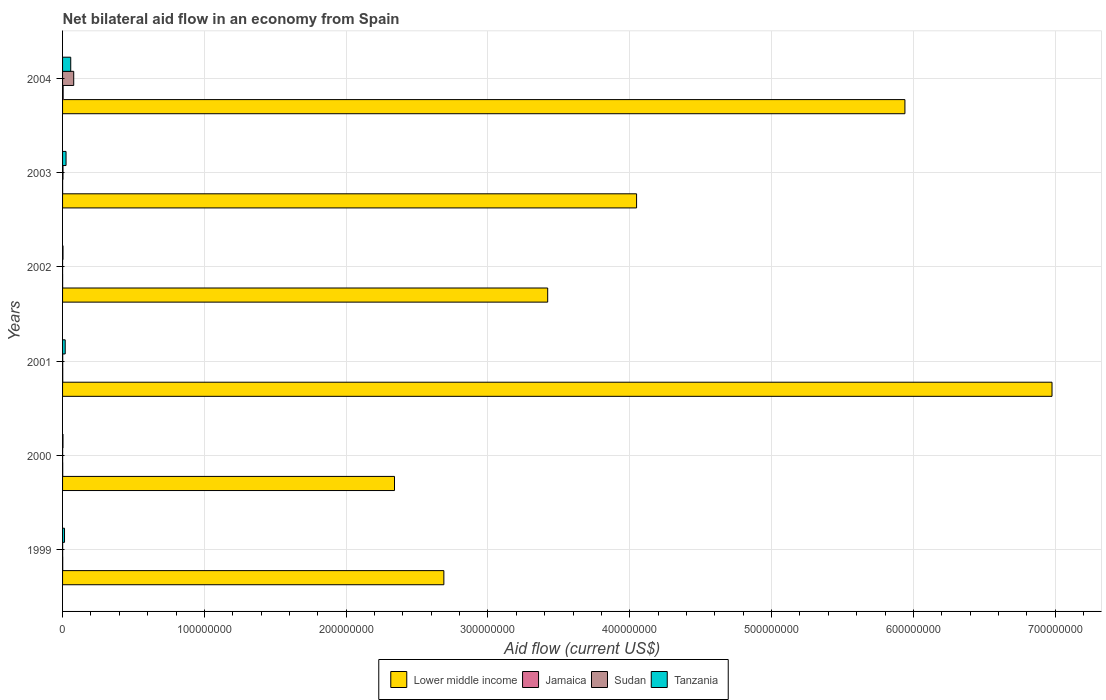How many bars are there on the 4th tick from the top?
Your answer should be compact. 4. How many bars are there on the 4th tick from the bottom?
Offer a very short reply. 4. What is the label of the 1st group of bars from the top?
Provide a succinct answer. 2004. Across all years, what is the maximum net bilateral aid flow in Sudan?
Give a very brief answer. 7.87e+06. Across all years, what is the minimum net bilateral aid flow in Lower middle income?
Ensure brevity in your answer.  2.34e+08. In which year was the net bilateral aid flow in Tanzania maximum?
Your response must be concise. 2004. In which year was the net bilateral aid flow in Lower middle income minimum?
Offer a very short reply. 2000. What is the total net bilateral aid flow in Sudan in the graph?
Your answer should be compact. 8.38e+06. What is the difference between the net bilateral aid flow in Tanzania in 1999 and that in 2002?
Your answer should be very brief. 1.07e+06. What is the average net bilateral aid flow in Jamaica per year?
Offer a very short reply. 1.37e+05. In the year 1999, what is the difference between the net bilateral aid flow in Sudan and net bilateral aid flow in Tanzania?
Offer a terse response. -1.33e+06. In how many years, is the net bilateral aid flow in Lower middle income greater than 140000000 US$?
Give a very brief answer. 6. What is the ratio of the net bilateral aid flow in Tanzania in 2001 to that in 2002?
Offer a terse response. 6. Is the net bilateral aid flow in Sudan in 2003 less than that in 2004?
Give a very brief answer. Yes. Is the difference between the net bilateral aid flow in Sudan in 2000 and 2002 greater than the difference between the net bilateral aid flow in Tanzania in 2000 and 2002?
Offer a terse response. Yes. What is the difference between the highest and the second highest net bilateral aid flow in Tanzania?
Ensure brevity in your answer.  3.31e+06. What is the difference between the highest and the lowest net bilateral aid flow in Lower middle income?
Offer a very short reply. 4.64e+08. In how many years, is the net bilateral aid flow in Tanzania greater than the average net bilateral aid flow in Tanzania taken over all years?
Offer a terse response. 2. Is it the case that in every year, the sum of the net bilateral aid flow in Jamaica and net bilateral aid flow in Lower middle income is greater than the sum of net bilateral aid flow in Tanzania and net bilateral aid flow in Sudan?
Offer a terse response. Yes. What does the 3rd bar from the top in 2001 represents?
Provide a succinct answer. Jamaica. What does the 3rd bar from the bottom in 2000 represents?
Offer a terse response. Sudan. How many years are there in the graph?
Give a very brief answer. 6. Are the values on the major ticks of X-axis written in scientific E-notation?
Keep it short and to the point. No. Does the graph contain any zero values?
Keep it short and to the point. No. Where does the legend appear in the graph?
Your answer should be very brief. Bottom center. How many legend labels are there?
Make the answer very short. 4. How are the legend labels stacked?
Your response must be concise. Horizontal. What is the title of the graph?
Keep it short and to the point. Net bilateral aid flow in an economy from Spain. What is the label or title of the X-axis?
Provide a succinct answer. Aid flow (current US$). What is the Aid flow (current US$) of Lower middle income in 1999?
Give a very brief answer. 2.69e+08. What is the Aid flow (current US$) of Tanzania in 1999?
Offer a very short reply. 1.38e+06. What is the Aid flow (current US$) of Lower middle income in 2000?
Make the answer very short. 2.34e+08. What is the Aid flow (current US$) of Jamaica in 2000?
Offer a terse response. 1.10e+05. What is the Aid flow (current US$) in Tanzania in 2000?
Provide a succinct answer. 2.90e+05. What is the Aid flow (current US$) of Lower middle income in 2001?
Make the answer very short. 6.98e+08. What is the Aid flow (current US$) of Sudan in 2001?
Your answer should be compact. 1.00e+05. What is the Aid flow (current US$) of Tanzania in 2001?
Offer a very short reply. 1.86e+06. What is the Aid flow (current US$) in Lower middle income in 2002?
Make the answer very short. 3.42e+08. What is the Aid flow (current US$) in Sudan in 2002?
Give a very brief answer. 10000. What is the Aid flow (current US$) in Tanzania in 2002?
Offer a very short reply. 3.10e+05. What is the Aid flow (current US$) in Lower middle income in 2003?
Offer a very short reply. 4.05e+08. What is the Aid flow (current US$) of Jamaica in 2003?
Make the answer very short. 4.00e+04. What is the Aid flow (current US$) of Tanzania in 2003?
Keep it short and to the point. 2.45e+06. What is the Aid flow (current US$) in Lower middle income in 2004?
Offer a terse response. 5.94e+08. What is the Aid flow (current US$) in Jamaica in 2004?
Offer a very short reply. 4.00e+05. What is the Aid flow (current US$) in Sudan in 2004?
Provide a short and direct response. 7.87e+06. What is the Aid flow (current US$) of Tanzania in 2004?
Keep it short and to the point. 5.76e+06. Across all years, what is the maximum Aid flow (current US$) in Lower middle income?
Give a very brief answer. 6.98e+08. Across all years, what is the maximum Aid flow (current US$) of Sudan?
Make the answer very short. 7.87e+06. Across all years, what is the maximum Aid flow (current US$) in Tanzania?
Your response must be concise. 5.76e+06. Across all years, what is the minimum Aid flow (current US$) in Lower middle income?
Provide a succinct answer. 2.34e+08. Across all years, what is the minimum Aid flow (current US$) in Sudan?
Ensure brevity in your answer.  10000. Across all years, what is the minimum Aid flow (current US$) in Tanzania?
Your response must be concise. 2.90e+05. What is the total Aid flow (current US$) in Lower middle income in the graph?
Provide a succinct answer. 2.54e+09. What is the total Aid flow (current US$) of Jamaica in the graph?
Your answer should be compact. 8.20e+05. What is the total Aid flow (current US$) in Sudan in the graph?
Provide a short and direct response. 8.38e+06. What is the total Aid flow (current US$) of Tanzania in the graph?
Your response must be concise. 1.20e+07. What is the difference between the Aid flow (current US$) in Lower middle income in 1999 and that in 2000?
Give a very brief answer. 3.48e+07. What is the difference between the Aid flow (current US$) of Sudan in 1999 and that in 2000?
Keep it short and to the point. 10000. What is the difference between the Aid flow (current US$) of Tanzania in 1999 and that in 2000?
Ensure brevity in your answer.  1.09e+06. What is the difference between the Aid flow (current US$) in Lower middle income in 1999 and that in 2001?
Your response must be concise. -4.29e+08. What is the difference between the Aid flow (current US$) in Jamaica in 1999 and that in 2001?
Keep it short and to the point. -10000. What is the difference between the Aid flow (current US$) of Tanzania in 1999 and that in 2001?
Ensure brevity in your answer.  -4.80e+05. What is the difference between the Aid flow (current US$) of Lower middle income in 1999 and that in 2002?
Keep it short and to the point. -7.32e+07. What is the difference between the Aid flow (current US$) in Tanzania in 1999 and that in 2002?
Keep it short and to the point. 1.07e+06. What is the difference between the Aid flow (current US$) of Lower middle income in 1999 and that in 2003?
Make the answer very short. -1.36e+08. What is the difference between the Aid flow (current US$) in Jamaica in 1999 and that in 2003?
Your answer should be very brief. 7.00e+04. What is the difference between the Aid flow (current US$) of Tanzania in 1999 and that in 2003?
Make the answer very short. -1.07e+06. What is the difference between the Aid flow (current US$) in Lower middle income in 1999 and that in 2004?
Make the answer very short. -3.25e+08. What is the difference between the Aid flow (current US$) in Jamaica in 1999 and that in 2004?
Provide a succinct answer. -2.90e+05. What is the difference between the Aid flow (current US$) in Sudan in 1999 and that in 2004?
Offer a very short reply. -7.82e+06. What is the difference between the Aid flow (current US$) in Tanzania in 1999 and that in 2004?
Keep it short and to the point. -4.38e+06. What is the difference between the Aid flow (current US$) in Lower middle income in 2000 and that in 2001?
Give a very brief answer. -4.64e+08. What is the difference between the Aid flow (current US$) of Sudan in 2000 and that in 2001?
Your answer should be compact. -6.00e+04. What is the difference between the Aid flow (current US$) in Tanzania in 2000 and that in 2001?
Provide a succinct answer. -1.57e+06. What is the difference between the Aid flow (current US$) in Lower middle income in 2000 and that in 2002?
Give a very brief answer. -1.08e+08. What is the difference between the Aid flow (current US$) of Sudan in 2000 and that in 2002?
Your answer should be compact. 3.00e+04. What is the difference between the Aid flow (current US$) of Tanzania in 2000 and that in 2002?
Make the answer very short. -2.00e+04. What is the difference between the Aid flow (current US$) in Lower middle income in 2000 and that in 2003?
Make the answer very short. -1.71e+08. What is the difference between the Aid flow (current US$) of Tanzania in 2000 and that in 2003?
Your answer should be very brief. -2.16e+06. What is the difference between the Aid flow (current US$) of Lower middle income in 2000 and that in 2004?
Offer a terse response. -3.60e+08. What is the difference between the Aid flow (current US$) in Sudan in 2000 and that in 2004?
Make the answer very short. -7.83e+06. What is the difference between the Aid flow (current US$) of Tanzania in 2000 and that in 2004?
Your answer should be compact. -5.47e+06. What is the difference between the Aid flow (current US$) in Lower middle income in 2001 and that in 2002?
Your answer should be compact. 3.56e+08. What is the difference between the Aid flow (current US$) of Jamaica in 2001 and that in 2002?
Ensure brevity in your answer.  8.00e+04. What is the difference between the Aid flow (current US$) of Tanzania in 2001 and that in 2002?
Your answer should be compact. 1.55e+06. What is the difference between the Aid flow (current US$) of Lower middle income in 2001 and that in 2003?
Offer a very short reply. 2.93e+08. What is the difference between the Aid flow (current US$) in Tanzania in 2001 and that in 2003?
Provide a short and direct response. -5.90e+05. What is the difference between the Aid flow (current US$) in Lower middle income in 2001 and that in 2004?
Provide a succinct answer. 1.04e+08. What is the difference between the Aid flow (current US$) in Jamaica in 2001 and that in 2004?
Give a very brief answer. -2.80e+05. What is the difference between the Aid flow (current US$) of Sudan in 2001 and that in 2004?
Provide a succinct answer. -7.77e+06. What is the difference between the Aid flow (current US$) in Tanzania in 2001 and that in 2004?
Keep it short and to the point. -3.90e+06. What is the difference between the Aid flow (current US$) in Lower middle income in 2002 and that in 2003?
Your answer should be compact. -6.27e+07. What is the difference between the Aid flow (current US$) of Jamaica in 2002 and that in 2003?
Keep it short and to the point. 0. What is the difference between the Aid flow (current US$) in Sudan in 2002 and that in 2003?
Offer a very short reply. -3.00e+05. What is the difference between the Aid flow (current US$) in Tanzania in 2002 and that in 2003?
Your response must be concise. -2.14e+06. What is the difference between the Aid flow (current US$) in Lower middle income in 2002 and that in 2004?
Your response must be concise. -2.52e+08. What is the difference between the Aid flow (current US$) of Jamaica in 2002 and that in 2004?
Your answer should be compact. -3.60e+05. What is the difference between the Aid flow (current US$) of Sudan in 2002 and that in 2004?
Ensure brevity in your answer.  -7.86e+06. What is the difference between the Aid flow (current US$) of Tanzania in 2002 and that in 2004?
Your answer should be very brief. -5.45e+06. What is the difference between the Aid flow (current US$) in Lower middle income in 2003 and that in 2004?
Provide a succinct answer. -1.89e+08. What is the difference between the Aid flow (current US$) of Jamaica in 2003 and that in 2004?
Your answer should be very brief. -3.60e+05. What is the difference between the Aid flow (current US$) in Sudan in 2003 and that in 2004?
Your answer should be compact. -7.56e+06. What is the difference between the Aid flow (current US$) in Tanzania in 2003 and that in 2004?
Your answer should be very brief. -3.31e+06. What is the difference between the Aid flow (current US$) of Lower middle income in 1999 and the Aid flow (current US$) of Jamaica in 2000?
Offer a terse response. 2.69e+08. What is the difference between the Aid flow (current US$) of Lower middle income in 1999 and the Aid flow (current US$) of Sudan in 2000?
Make the answer very short. 2.69e+08. What is the difference between the Aid flow (current US$) in Lower middle income in 1999 and the Aid flow (current US$) in Tanzania in 2000?
Give a very brief answer. 2.69e+08. What is the difference between the Aid flow (current US$) of Lower middle income in 1999 and the Aid flow (current US$) of Jamaica in 2001?
Give a very brief answer. 2.69e+08. What is the difference between the Aid flow (current US$) in Lower middle income in 1999 and the Aid flow (current US$) in Sudan in 2001?
Provide a short and direct response. 2.69e+08. What is the difference between the Aid flow (current US$) in Lower middle income in 1999 and the Aid flow (current US$) in Tanzania in 2001?
Make the answer very short. 2.67e+08. What is the difference between the Aid flow (current US$) of Jamaica in 1999 and the Aid flow (current US$) of Sudan in 2001?
Your answer should be very brief. 10000. What is the difference between the Aid flow (current US$) in Jamaica in 1999 and the Aid flow (current US$) in Tanzania in 2001?
Give a very brief answer. -1.75e+06. What is the difference between the Aid flow (current US$) of Sudan in 1999 and the Aid flow (current US$) of Tanzania in 2001?
Your response must be concise. -1.81e+06. What is the difference between the Aid flow (current US$) in Lower middle income in 1999 and the Aid flow (current US$) in Jamaica in 2002?
Give a very brief answer. 2.69e+08. What is the difference between the Aid flow (current US$) in Lower middle income in 1999 and the Aid flow (current US$) in Sudan in 2002?
Your response must be concise. 2.69e+08. What is the difference between the Aid flow (current US$) of Lower middle income in 1999 and the Aid flow (current US$) of Tanzania in 2002?
Provide a short and direct response. 2.69e+08. What is the difference between the Aid flow (current US$) of Jamaica in 1999 and the Aid flow (current US$) of Sudan in 2002?
Give a very brief answer. 1.00e+05. What is the difference between the Aid flow (current US$) in Jamaica in 1999 and the Aid flow (current US$) in Tanzania in 2002?
Make the answer very short. -2.00e+05. What is the difference between the Aid flow (current US$) in Lower middle income in 1999 and the Aid flow (current US$) in Jamaica in 2003?
Keep it short and to the point. 2.69e+08. What is the difference between the Aid flow (current US$) in Lower middle income in 1999 and the Aid flow (current US$) in Sudan in 2003?
Provide a succinct answer. 2.69e+08. What is the difference between the Aid flow (current US$) of Lower middle income in 1999 and the Aid flow (current US$) of Tanzania in 2003?
Make the answer very short. 2.66e+08. What is the difference between the Aid flow (current US$) in Jamaica in 1999 and the Aid flow (current US$) in Sudan in 2003?
Keep it short and to the point. -2.00e+05. What is the difference between the Aid flow (current US$) in Jamaica in 1999 and the Aid flow (current US$) in Tanzania in 2003?
Your response must be concise. -2.34e+06. What is the difference between the Aid flow (current US$) in Sudan in 1999 and the Aid flow (current US$) in Tanzania in 2003?
Ensure brevity in your answer.  -2.40e+06. What is the difference between the Aid flow (current US$) in Lower middle income in 1999 and the Aid flow (current US$) in Jamaica in 2004?
Provide a succinct answer. 2.68e+08. What is the difference between the Aid flow (current US$) in Lower middle income in 1999 and the Aid flow (current US$) in Sudan in 2004?
Your answer should be very brief. 2.61e+08. What is the difference between the Aid flow (current US$) of Lower middle income in 1999 and the Aid flow (current US$) of Tanzania in 2004?
Your response must be concise. 2.63e+08. What is the difference between the Aid flow (current US$) in Jamaica in 1999 and the Aid flow (current US$) in Sudan in 2004?
Provide a short and direct response. -7.76e+06. What is the difference between the Aid flow (current US$) in Jamaica in 1999 and the Aid flow (current US$) in Tanzania in 2004?
Provide a short and direct response. -5.65e+06. What is the difference between the Aid flow (current US$) of Sudan in 1999 and the Aid flow (current US$) of Tanzania in 2004?
Your response must be concise. -5.71e+06. What is the difference between the Aid flow (current US$) in Lower middle income in 2000 and the Aid flow (current US$) in Jamaica in 2001?
Make the answer very short. 2.34e+08. What is the difference between the Aid flow (current US$) of Lower middle income in 2000 and the Aid flow (current US$) of Sudan in 2001?
Your answer should be very brief. 2.34e+08. What is the difference between the Aid flow (current US$) in Lower middle income in 2000 and the Aid flow (current US$) in Tanzania in 2001?
Offer a terse response. 2.32e+08. What is the difference between the Aid flow (current US$) in Jamaica in 2000 and the Aid flow (current US$) in Sudan in 2001?
Your response must be concise. 10000. What is the difference between the Aid flow (current US$) of Jamaica in 2000 and the Aid flow (current US$) of Tanzania in 2001?
Ensure brevity in your answer.  -1.75e+06. What is the difference between the Aid flow (current US$) of Sudan in 2000 and the Aid flow (current US$) of Tanzania in 2001?
Your answer should be very brief. -1.82e+06. What is the difference between the Aid flow (current US$) of Lower middle income in 2000 and the Aid flow (current US$) of Jamaica in 2002?
Give a very brief answer. 2.34e+08. What is the difference between the Aid flow (current US$) in Lower middle income in 2000 and the Aid flow (current US$) in Sudan in 2002?
Your response must be concise. 2.34e+08. What is the difference between the Aid flow (current US$) of Lower middle income in 2000 and the Aid flow (current US$) of Tanzania in 2002?
Provide a succinct answer. 2.34e+08. What is the difference between the Aid flow (current US$) of Jamaica in 2000 and the Aid flow (current US$) of Sudan in 2002?
Your answer should be very brief. 1.00e+05. What is the difference between the Aid flow (current US$) of Lower middle income in 2000 and the Aid flow (current US$) of Jamaica in 2003?
Your response must be concise. 2.34e+08. What is the difference between the Aid flow (current US$) of Lower middle income in 2000 and the Aid flow (current US$) of Sudan in 2003?
Offer a very short reply. 2.34e+08. What is the difference between the Aid flow (current US$) in Lower middle income in 2000 and the Aid flow (current US$) in Tanzania in 2003?
Give a very brief answer. 2.32e+08. What is the difference between the Aid flow (current US$) in Jamaica in 2000 and the Aid flow (current US$) in Tanzania in 2003?
Offer a terse response. -2.34e+06. What is the difference between the Aid flow (current US$) of Sudan in 2000 and the Aid flow (current US$) of Tanzania in 2003?
Keep it short and to the point. -2.41e+06. What is the difference between the Aid flow (current US$) of Lower middle income in 2000 and the Aid flow (current US$) of Jamaica in 2004?
Offer a very short reply. 2.34e+08. What is the difference between the Aid flow (current US$) in Lower middle income in 2000 and the Aid flow (current US$) in Sudan in 2004?
Your answer should be compact. 2.26e+08. What is the difference between the Aid flow (current US$) of Lower middle income in 2000 and the Aid flow (current US$) of Tanzania in 2004?
Ensure brevity in your answer.  2.28e+08. What is the difference between the Aid flow (current US$) in Jamaica in 2000 and the Aid flow (current US$) in Sudan in 2004?
Provide a short and direct response. -7.76e+06. What is the difference between the Aid flow (current US$) of Jamaica in 2000 and the Aid flow (current US$) of Tanzania in 2004?
Keep it short and to the point. -5.65e+06. What is the difference between the Aid flow (current US$) of Sudan in 2000 and the Aid flow (current US$) of Tanzania in 2004?
Offer a terse response. -5.72e+06. What is the difference between the Aid flow (current US$) in Lower middle income in 2001 and the Aid flow (current US$) in Jamaica in 2002?
Make the answer very short. 6.98e+08. What is the difference between the Aid flow (current US$) of Lower middle income in 2001 and the Aid flow (current US$) of Sudan in 2002?
Offer a very short reply. 6.98e+08. What is the difference between the Aid flow (current US$) of Lower middle income in 2001 and the Aid flow (current US$) of Tanzania in 2002?
Ensure brevity in your answer.  6.97e+08. What is the difference between the Aid flow (current US$) in Jamaica in 2001 and the Aid flow (current US$) in Tanzania in 2002?
Provide a short and direct response. -1.90e+05. What is the difference between the Aid flow (current US$) of Sudan in 2001 and the Aid flow (current US$) of Tanzania in 2002?
Give a very brief answer. -2.10e+05. What is the difference between the Aid flow (current US$) in Lower middle income in 2001 and the Aid flow (current US$) in Jamaica in 2003?
Offer a very short reply. 6.98e+08. What is the difference between the Aid flow (current US$) of Lower middle income in 2001 and the Aid flow (current US$) of Sudan in 2003?
Your answer should be compact. 6.97e+08. What is the difference between the Aid flow (current US$) in Lower middle income in 2001 and the Aid flow (current US$) in Tanzania in 2003?
Make the answer very short. 6.95e+08. What is the difference between the Aid flow (current US$) in Jamaica in 2001 and the Aid flow (current US$) in Tanzania in 2003?
Provide a succinct answer. -2.33e+06. What is the difference between the Aid flow (current US$) in Sudan in 2001 and the Aid flow (current US$) in Tanzania in 2003?
Your answer should be compact. -2.35e+06. What is the difference between the Aid flow (current US$) in Lower middle income in 2001 and the Aid flow (current US$) in Jamaica in 2004?
Your response must be concise. 6.97e+08. What is the difference between the Aid flow (current US$) of Lower middle income in 2001 and the Aid flow (current US$) of Sudan in 2004?
Offer a terse response. 6.90e+08. What is the difference between the Aid flow (current US$) in Lower middle income in 2001 and the Aid flow (current US$) in Tanzania in 2004?
Provide a succinct answer. 6.92e+08. What is the difference between the Aid flow (current US$) of Jamaica in 2001 and the Aid flow (current US$) of Sudan in 2004?
Offer a very short reply. -7.75e+06. What is the difference between the Aid flow (current US$) in Jamaica in 2001 and the Aid flow (current US$) in Tanzania in 2004?
Your response must be concise. -5.64e+06. What is the difference between the Aid flow (current US$) of Sudan in 2001 and the Aid flow (current US$) of Tanzania in 2004?
Give a very brief answer. -5.66e+06. What is the difference between the Aid flow (current US$) in Lower middle income in 2002 and the Aid flow (current US$) in Jamaica in 2003?
Your answer should be compact. 3.42e+08. What is the difference between the Aid flow (current US$) of Lower middle income in 2002 and the Aid flow (current US$) of Sudan in 2003?
Keep it short and to the point. 3.42e+08. What is the difference between the Aid flow (current US$) in Lower middle income in 2002 and the Aid flow (current US$) in Tanzania in 2003?
Provide a succinct answer. 3.40e+08. What is the difference between the Aid flow (current US$) in Jamaica in 2002 and the Aid flow (current US$) in Sudan in 2003?
Your answer should be compact. -2.70e+05. What is the difference between the Aid flow (current US$) of Jamaica in 2002 and the Aid flow (current US$) of Tanzania in 2003?
Your answer should be very brief. -2.41e+06. What is the difference between the Aid flow (current US$) in Sudan in 2002 and the Aid flow (current US$) in Tanzania in 2003?
Your answer should be compact. -2.44e+06. What is the difference between the Aid flow (current US$) of Lower middle income in 2002 and the Aid flow (current US$) of Jamaica in 2004?
Your answer should be very brief. 3.42e+08. What is the difference between the Aid flow (current US$) in Lower middle income in 2002 and the Aid flow (current US$) in Sudan in 2004?
Provide a short and direct response. 3.34e+08. What is the difference between the Aid flow (current US$) of Lower middle income in 2002 and the Aid flow (current US$) of Tanzania in 2004?
Provide a succinct answer. 3.36e+08. What is the difference between the Aid flow (current US$) of Jamaica in 2002 and the Aid flow (current US$) of Sudan in 2004?
Give a very brief answer. -7.83e+06. What is the difference between the Aid flow (current US$) in Jamaica in 2002 and the Aid flow (current US$) in Tanzania in 2004?
Ensure brevity in your answer.  -5.72e+06. What is the difference between the Aid flow (current US$) of Sudan in 2002 and the Aid flow (current US$) of Tanzania in 2004?
Offer a terse response. -5.75e+06. What is the difference between the Aid flow (current US$) of Lower middle income in 2003 and the Aid flow (current US$) of Jamaica in 2004?
Your response must be concise. 4.04e+08. What is the difference between the Aid flow (current US$) in Lower middle income in 2003 and the Aid flow (current US$) in Sudan in 2004?
Make the answer very short. 3.97e+08. What is the difference between the Aid flow (current US$) of Lower middle income in 2003 and the Aid flow (current US$) of Tanzania in 2004?
Make the answer very short. 3.99e+08. What is the difference between the Aid flow (current US$) in Jamaica in 2003 and the Aid flow (current US$) in Sudan in 2004?
Make the answer very short. -7.83e+06. What is the difference between the Aid flow (current US$) in Jamaica in 2003 and the Aid flow (current US$) in Tanzania in 2004?
Ensure brevity in your answer.  -5.72e+06. What is the difference between the Aid flow (current US$) of Sudan in 2003 and the Aid flow (current US$) of Tanzania in 2004?
Give a very brief answer. -5.45e+06. What is the average Aid flow (current US$) of Lower middle income per year?
Give a very brief answer. 4.24e+08. What is the average Aid flow (current US$) of Jamaica per year?
Make the answer very short. 1.37e+05. What is the average Aid flow (current US$) in Sudan per year?
Offer a very short reply. 1.40e+06. What is the average Aid flow (current US$) in Tanzania per year?
Provide a short and direct response. 2.01e+06. In the year 1999, what is the difference between the Aid flow (current US$) in Lower middle income and Aid flow (current US$) in Jamaica?
Make the answer very short. 2.69e+08. In the year 1999, what is the difference between the Aid flow (current US$) in Lower middle income and Aid flow (current US$) in Sudan?
Make the answer very short. 2.69e+08. In the year 1999, what is the difference between the Aid flow (current US$) in Lower middle income and Aid flow (current US$) in Tanzania?
Your response must be concise. 2.68e+08. In the year 1999, what is the difference between the Aid flow (current US$) of Jamaica and Aid flow (current US$) of Sudan?
Keep it short and to the point. 6.00e+04. In the year 1999, what is the difference between the Aid flow (current US$) in Jamaica and Aid flow (current US$) in Tanzania?
Ensure brevity in your answer.  -1.27e+06. In the year 1999, what is the difference between the Aid flow (current US$) of Sudan and Aid flow (current US$) of Tanzania?
Provide a short and direct response. -1.33e+06. In the year 2000, what is the difference between the Aid flow (current US$) in Lower middle income and Aid flow (current US$) in Jamaica?
Offer a very short reply. 2.34e+08. In the year 2000, what is the difference between the Aid flow (current US$) of Lower middle income and Aid flow (current US$) of Sudan?
Your response must be concise. 2.34e+08. In the year 2000, what is the difference between the Aid flow (current US$) of Lower middle income and Aid flow (current US$) of Tanzania?
Ensure brevity in your answer.  2.34e+08. In the year 2001, what is the difference between the Aid flow (current US$) in Lower middle income and Aid flow (current US$) in Jamaica?
Provide a succinct answer. 6.98e+08. In the year 2001, what is the difference between the Aid flow (current US$) of Lower middle income and Aid flow (current US$) of Sudan?
Offer a very short reply. 6.98e+08. In the year 2001, what is the difference between the Aid flow (current US$) in Lower middle income and Aid flow (current US$) in Tanzania?
Your answer should be compact. 6.96e+08. In the year 2001, what is the difference between the Aid flow (current US$) of Jamaica and Aid flow (current US$) of Tanzania?
Provide a succinct answer. -1.74e+06. In the year 2001, what is the difference between the Aid flow (current US$) of Sudan and Aid flow (current US$) of Tanzania?
Offer a terse response. -1.76e+06. In the year 2002, what is the difference between the Aid flow (current US$) in Lower middle income and Aid flow (current US$) in Jamaica?
Make the answer very short. 3.42e+08. In the year 2002, what is the difference between the Aid flow (current US$) of Lower middle income and Aid flow (current US$) of Sudan?
Your answer should be compact. 3.42e+08. In the year 2002, what is the difference between the Aid flow (current US$) of Lower middle income and Aid flow (current US$) of Tanzania?
Keep it short and to the point. 3.42e+08. In the year 2002, what is the difference between the Aid flow (current US$) in Jamaica and Aid flow (current US$) in Tanzania?
Make the answer very short. -2.70e+05. In the year 2002, what is the difference between the Aid flow (current US$) of Sudan and Aid flow (current US$) of Tanzania?
Your answer should be compact. -3.00e+05. In the year 2003, what is the difference between the Aid flow (current US$) of Lower middle income and Aid flow (current US$) of Jamaica?
Offer a very short reply. 4.05e+08. In the year 2003, what is the difference between the Aid flow (current US$) in Lower middle income and Aid flow (current US$) in Sudan?
Give a very brief answer. 4.04e+08. In the year 2003, what is the difference between the Aid flow (current US$) in Lower middle income and Aid flow (current US$) in Tanzania?
Your answer should be compact. 4.02e+08. In the year 2003, what is the difference between the Aid flow (current US$) of Jamaica and Aid flow (current US$) of Sudan?
Offer a terse response. -2.70e+05. In the year 2003, what is the difference between the Aid flow (current US$) in Jamaica and Aid flow (current US$) in Tanzania?
Your answer should be compact. -2.41e+06. In the year 2003, what is the difference between the Aid flow (current US$) in Sudan and Aid flow (current US$) in Tanzania?
Offer a terse response. -2.14e+06. In the year 2004, what is the difference between the Aid flow (current US$) of Lower middle income and Aid flow (current US$) of Jamaica?
Provide a short and direct response. 5.94e+08. In the year 2004, what is the difference between the Aid flow (current US$) in Lower middle income and Aid flow (current US$) in Sudan?
Your response must be concise. 5.86e+08. In the year 2004, what is the difference between the Aid flow (current US$) in Lower middle income and Aid flow (current US$) in Tanzania?
Make the answer very short. 5.88e+08. In the year 2004, what is the difference between the Aid flow (current US$) in Jamaica and Aid flow (current US$) in Sudan?
Keep it short and to the point. -7.47e+06. In the year 2004, what is the difference between the Aid flow (current US$) in Jamaica and Aid flow (current US$) in Tanzania?
Your answer should be compact. -5.36e+06. In the year 2004, what is the difference between the Aid flow (current US$) of Sudan and Aid flow (current US$) of Tanzania?
Your answer should be compact. 2.11e+06. What is the ratio of the Aid flow (current US$) of Lower middle income in 1999 to that in 2000?
Make the answer very short. 1.15. What is the ratio of the Aid flow (current US$) of Jamaica in 1999 to that in 2000?
Your response must be concise. 1. What is the ratio of the Aid flow (current US$) in Sudan in 1999 to that in 2000?
Make the answer very short. 1.25. What is the ratio of the Aid flow (current US$) in Tanzania in 1999 to that in 2000?
Make the answer very short. 4.76. What is the ratio of the Aid flow (current US$) of Lower middle income in 1999 to that in 2001?
Ensure brevity in your answer.  0.39. What is the ratio of the Aid flow (current US$) in Sudan in 1999 to that in 2001?
Your answer should be very brief. 0.5. What is the ratio of the Aid flow (current US$) of Tanzania in 1999 to that in 2001?
Your answer should be compact. 0.74. What is the ratio of the Aid flow (current US$) in Lower middle income in 1999 to that in 2002?
Your answer should be very brief. 0.79. What is the ratio of the Aid flow (current US$) of Jamaica in 1999 to that in 2002?
Make the answer very short. 2.75. What is the ratio of the Aid flow (current US$) in Tanzania in 1999 to that in 2002?
Your response must be concise. 4.45. What is the ratio of the Aid flow (current US$) in Lower middle income in 1999 to that in 2003?
Ensure brevity in your answer.  0.66. What is the ratio of the Aid flow (current US$) in Jamaica in 1999 to that in 2003?
Provide a succinct answer. 2.75. What is the ratio of the Aid flow (current US$) of Sudan in 1999 to that in 2003?
Provide a short and direct response. 0.16. What is the ratio of the Aid flow (current US$) in Tanzania in 1999 to that in 2003?
Provide a short and direct response. 0.56. What is the ratio of the Aid flow (current US$) of Lower middle income in 1999 to that in 2004?
Make the answer very short. 0.45. What is the ratio of the Aid flow (current US$) in Jamaica in 1999 to that in 2004?
Provide a succinct answer. 0.28. What is the ratio of the Aid flow (current US$) in Sudan in 1999 to that in 2004?
Your answer should be very brief. 0.01. What is the ratio of the Aid flow (current US$) in Tanzania in 1999 to that in 2004?
Keep it short and to the point. 0.24. What is the ratio of the Aid flow (current US$) in Lower middle income in 2000 to that in 2001?
Provide a short and direct response. 0.34. What is the ratio of the Aid flow (current US$) of Jamaica in 2000 to that in 2001?
Your response must be concise. 0.92. What is the ratio of the Aid flow (current US$) in Tanzania in 2000 to that in 2001?
Provide a short and direct response. 0.16. What is the ratio of the Aid flow (current US$) in Lower middle income in 2000 to that in 2002?
Ensure brevity in your answer.  0.68. What is the ratio of the Aid flow (current US$) of Jamaica in 2000 to that in 2002?
Provide a succinct answer. 2.75. What is the ratio of the Aid flow (current US$) in Sudan in 2000 to that in 2002?
Your answer should be compact. 4. What is the ratio of the Aid flow (current US$) in Tanzania in 2000 to that in 2002?
Your answer should be compact. 0.94. What is the ratio of the Aid flow (current US$) of Lower middle income in 2000 to that in 2003?
Keep it short and to the point. 0.58. What is the ratio of the Aid flow (current US$) of Jamaica in 2000 to that in 2003?
Your answer should be very brief. 2.75. What is the ratio of the Aid flow (current US$) of Sudan in 2000 to that in 2003?
Your answer should be compact. 0.13. What is the ratio of the Aid flow (current US$) of Tanzania in 2000 to that in 2003?
Your response must be concise. 0.12. What is the ratio of the Aid flow (current US$) of Lower middle income in 2000 to that in 2004?
Your response must be concise. 0.39. What is the ratio of the Aid flow (current US$) of Jamaica in 2000 to that in 2004?
Provide a short and direct response. 0.28. What is the ratio of the Aid flow (current US$) in Sudan in 2000 to that in 2004?
Keep it short and to the point. 0.01. What is the ratio of the Aid flow (current US$) of Tanzania in 2000 to that in 2004?
Give a very brief answer. 0.05. What is the ratio of the Aid flow (current US$) of Lower middle income in 2001 to that in 2002?
Provide a short and direct response. 2.04. What is the ratio of the Aid flow (current US$) of Jamaica in 2001 to that in 2002?
Make the answer very short. 3. What is the ratio of the Aid flow (current US$) in Sudan in 2001 to that in 2002?
Provide a short and direct response. 10. What is the ratio of the Aid flow (current US$) in Tanzania in 2001 to that in 2002?
Offer a terse response. 6. What is the ratio of the Aid flow (current US$) in Lower middle income in 2001 to that in 2003?
Your answer should be compact. 1.72. What is the ratio of the Aid flow (current US$) in Sudan in 2001 to that in 2003?
Provide a succinct answer. 0.32. What is the ratio of the Aid flow (current US$) of Tanzania in 2001 to that in 2003?
Your response must be concise. 0.76. What is the ratio of the Aid flow (current US$) of Lower middle income in 2001 to that in 2004?
Make the answer very short. 1.17. What is the ratio of the Aid flow (current US$) of Jamaica in 2001 to that in 2004?
Make the answer very short. 0.3. What is the ratio of the Aid flow (current US$) in Sudan in 2001 to that in 2004?
Offer a terse response. 0.01. What is the ratio of the Aid flow (current US$) of Tanzania in 2001 to that in 2004?
Offer a terse response. 0.32. What is the ratio of the Aid flow (current US$) of Lower middle income in 2002 to that in 2003?
Your response must be concise. 0.85. What is the ratio of the Aid flow (current US$) in Sudan in 2002 to that in 2003?
Your answer should be very brief. 0.03. What is the ratio of the Aid flow (current US$) in Tanzania in 2002 to that in 2003?
Offer a very short reply. 0.13. What is the ratio of the Aid flow (current US$) in Lower middle income in 2002 to that in 2004?
Offer a very short reply. 0.58. What is the ratio of the Aid flow (current US$) of Sudan in 2002 to that in 2004?
Give a very brief answer. 0. What is the ratio of the Aid flow (current US$) of Tanzania in 2002 to that in 2004?
Ensure brevity in your answer.  0.05. What is the ratio of the Aid flow (current US$) of Lower middle income in 2003 to that in 2004?
Give a very brief answer. 0.68. What is the ratio of the Aid flow (current US$) in Sudan in 2003 to that in 2004?
Your answer should be very brief. 0.04. What is the ratio of the Aid flow (current US$) in Tanzania in 2003 to that in 2004?
Offer a very short reply. 0.43. What is the difference between the highest and the second highest Aid flow (current US$) of Lower middle income?
Give a very brief answer. 1.04e+08. What is the difference between the highest and the second highest Aid flow (current US$) of Sudan?
Ensure brevity in your answer.  7.56e+06. What is the difference between the highest and the second highest Aid flow (current US$) in Tanzania?
Give a very brief answer. 3.31e+06. What is the difference between the highest and the lowest Aid flow (current US$) of Lower middle income?
Keep it short and to the point. 4.64e+08. What is the difference between the highest and the lowest Aid flow (current US$) in Jamaica?
Provide a short and direct response. 3.60e+05. What is the difference between the highest and the lowest Aid flow (current US$) in Sudan?
Provide a short and direct response. 7.86e+06. What is the difference between the highest and the lowest Aid flow (current US$) in Tanzania?
Offer a terse response. 5.47e+06. 